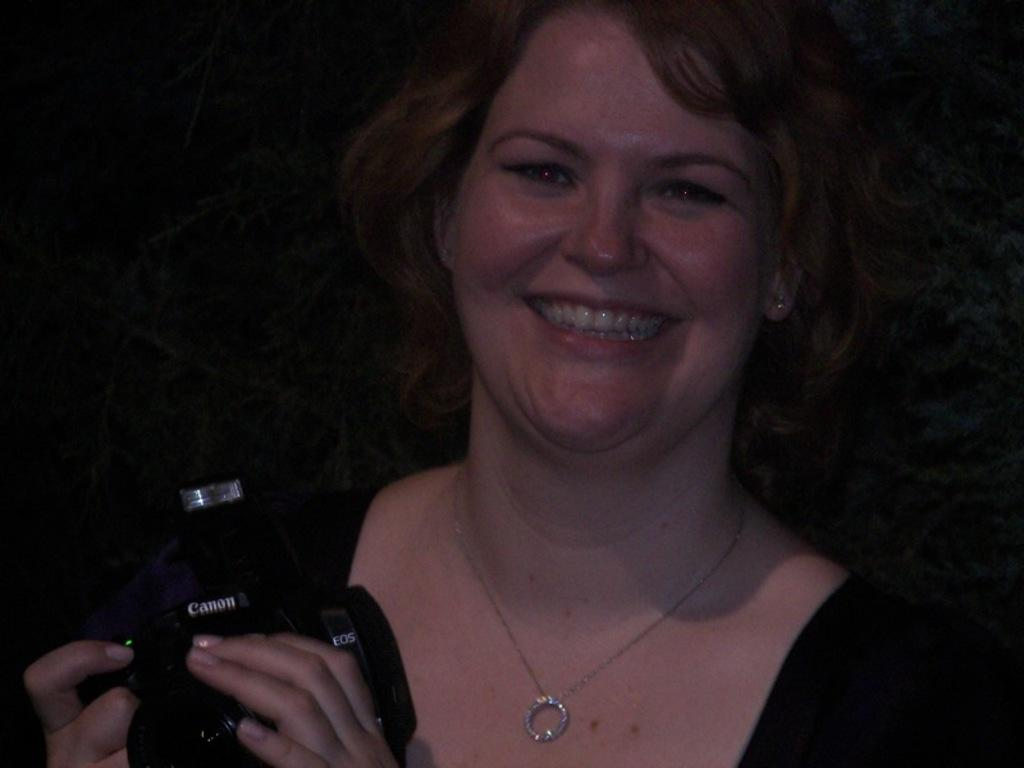What is the main subject of the image? The main subject of the image is a woman. What is the woman doing in the image? The woman is standing in the image. What object is the woman holding in her hand? The woman is holding a camera in her hand. What type of advice can be seen written on the woman's hair in the image? There is no advice written on the woman's hair in the image. How many dimes can be seen in the woman's hand in the image? There are no dimes present in the image. 